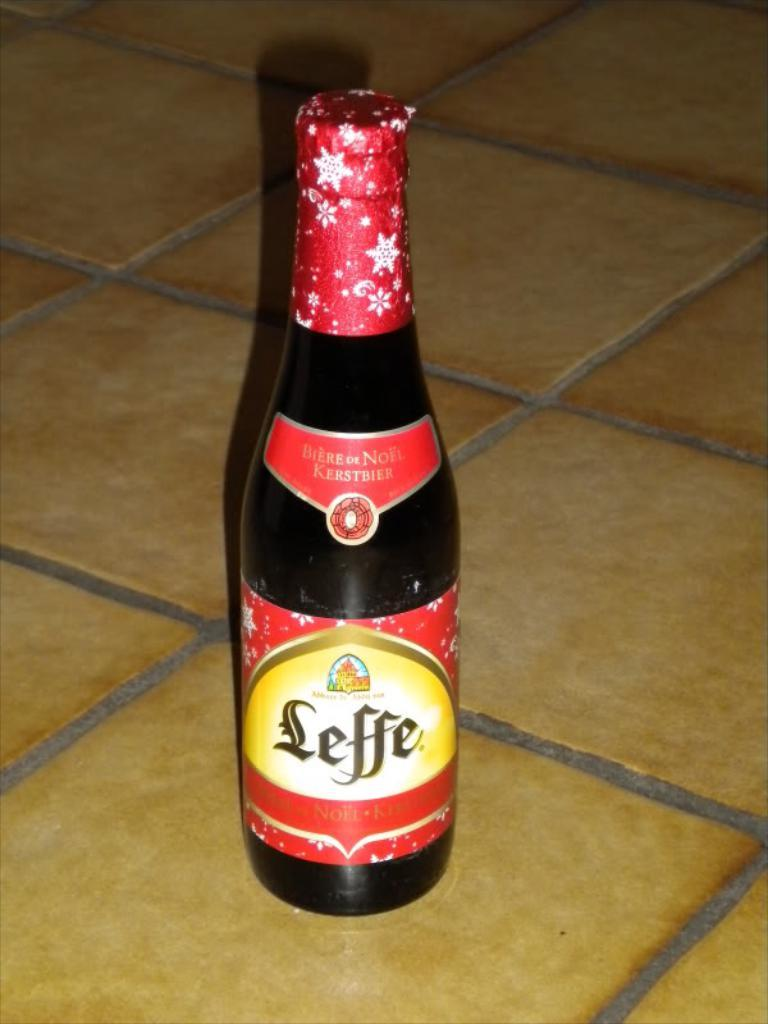<image>
Present a compact description of the photo's key features. A bottle of Leffe sits on a tiled counter. 